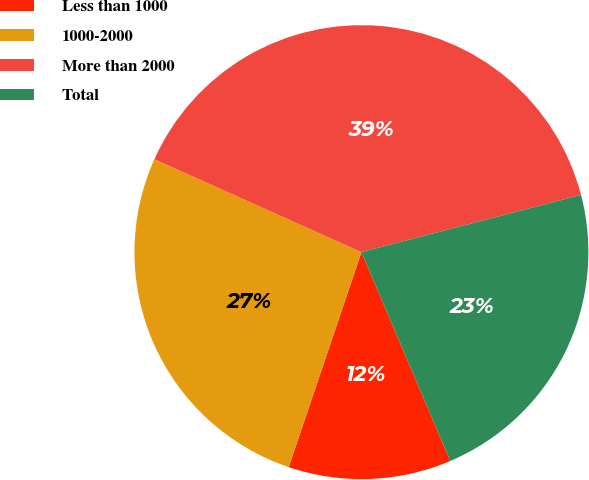<chart> <loc_0><loc_0><loc_500><loc_500><pie_chart><fcel>Less than 1000<fcel>1000-2000<fcel>More than 2000<fcel>Total<nl><fcel>11.6%<fcel>26.52%<fcel>39.23%<fcel>22.65%<nl></chart> 